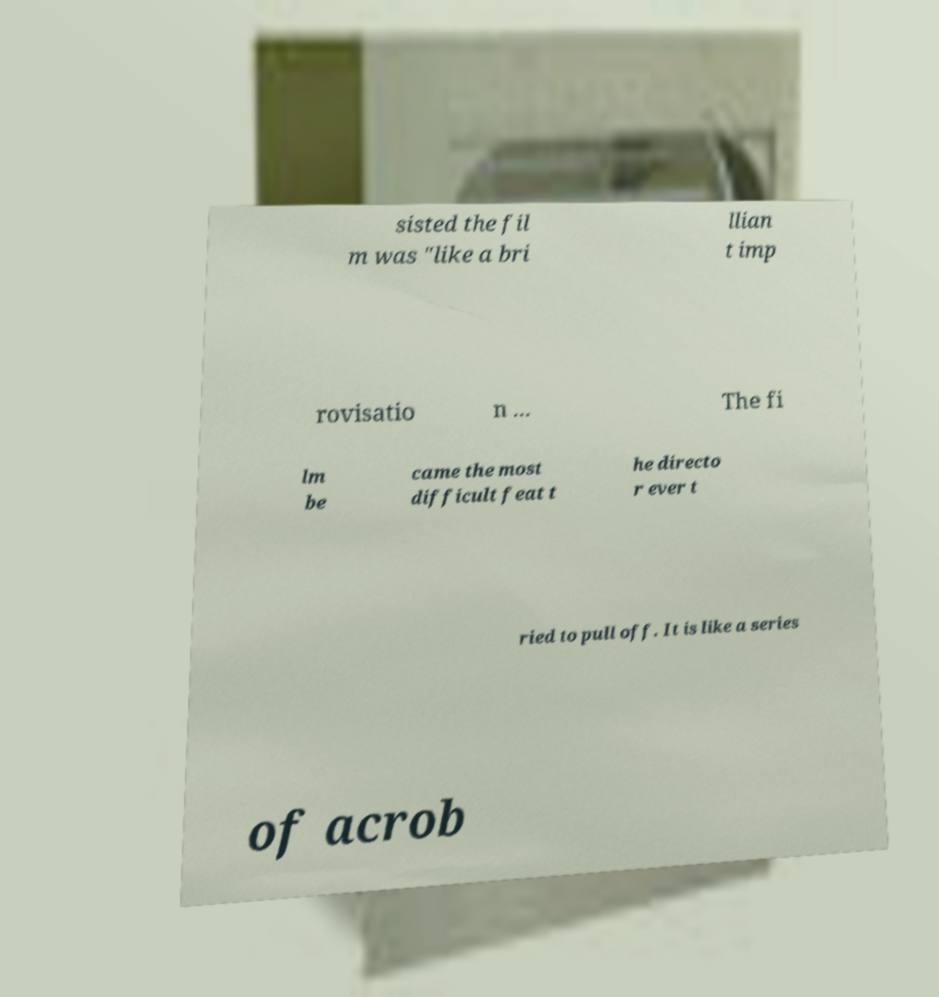Please identify and transcribe the text found in this image. sisted the fil m was "like a bri llian t imp rovisatio n ... The fi lm be came the most difficult feat t he directo r ever t ried to pull off. It is like a series of acrob 